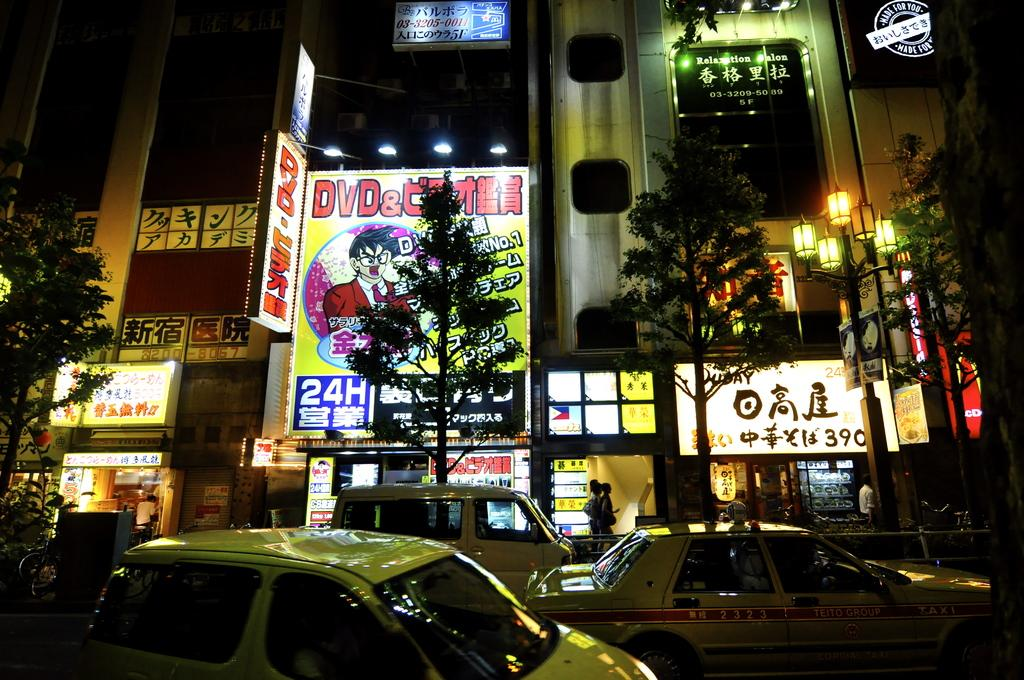What can be seen on the road in the image? There are vehicles on the road in the image. Who or what else is present in the image? There is a group of people in the image. What type of natural elements can be seen in the image? There are trees in the image. What type of man-made structures are visible in the image? There are buildings in the image. What type of illumination is present in the image? There are lights in the image. What type of signage or display can be seen in the image? There are boards in the image. What type of linen is being used by the committee in the image? There is no committee or linen present in the image. How does the rail system function in the image? There is no rail system present in the image. 